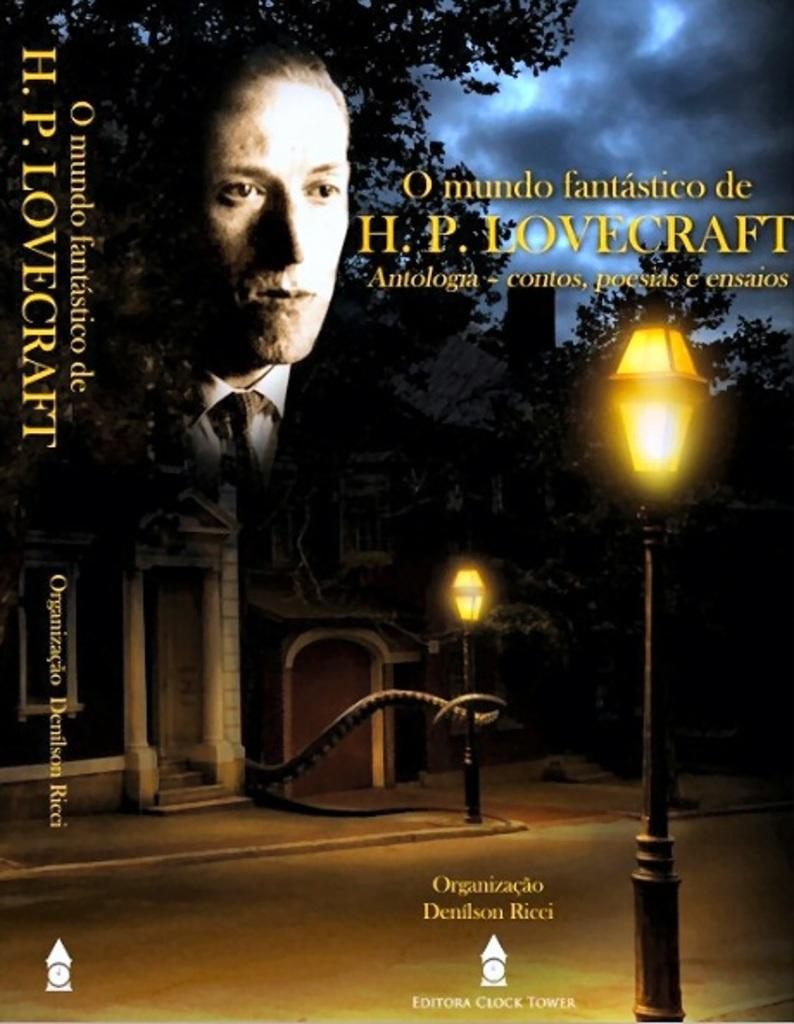<image>
Summarize the visual content of the image. The film is a foreign one with the name H.P. LOVECRAFT attached to it. 